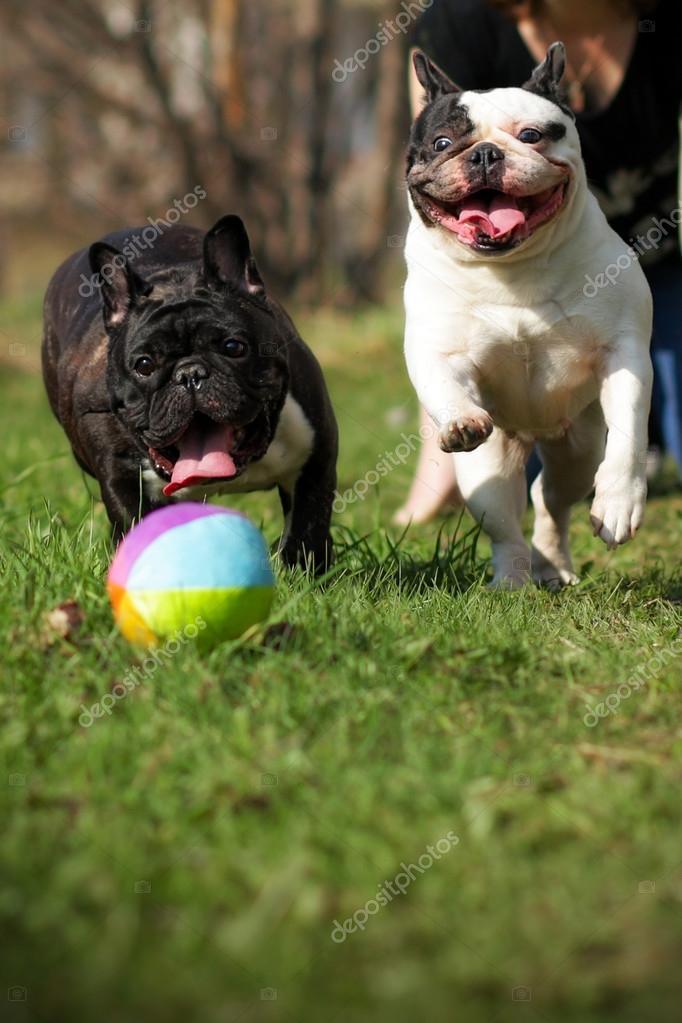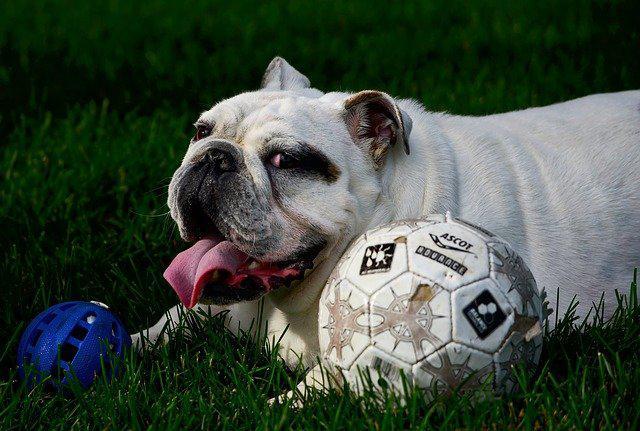The first image is the image on the left, the second image is the image on the right. Considering the images on both sides, is "In one image, a dog has its paw resting on top of a ball" valid? Answer yes or no. No. The first image is the image on the left, the second image is the image on the right. Considering the images on both sides, is "The left image contains exactly two dogs." valid? Answer yes or no. Yes. 